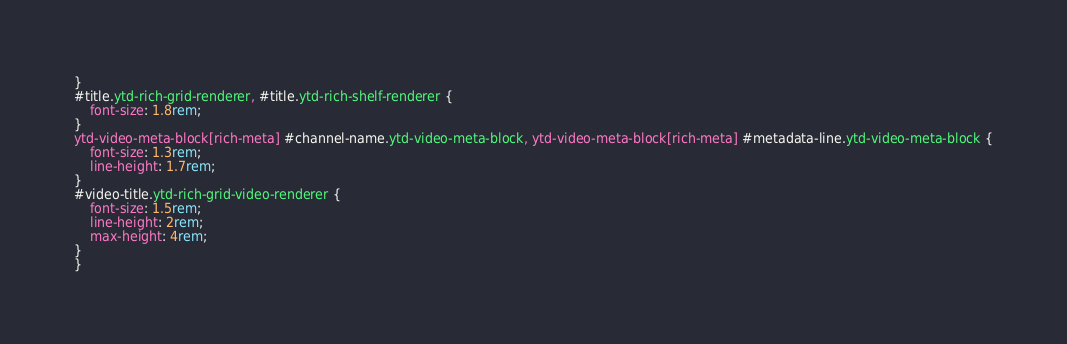Convert code to text. <code><loc_0><loc_0><loc_500><loc_500><_CSS_>}
#title.ytd-rich-grid-renderer, #title.ytd-rich-shelf-renderer {
    font-size: 1.8rem;
}
ytd-video-meta-block[rich-meta] #channel-name.ytd-video-meta-block, ytd-video-meta-block[rich-meta] #metadata-line.ytd-video-meta-block {
    font-size: 1.3rem;
    line-height: 1.7rem;
}
#video-title.ytd-rich-grid-video-renderer {
    font-size: 1.5rem;
    line-height: 2rem;
    max-height: 4rem;
}
}</code> 